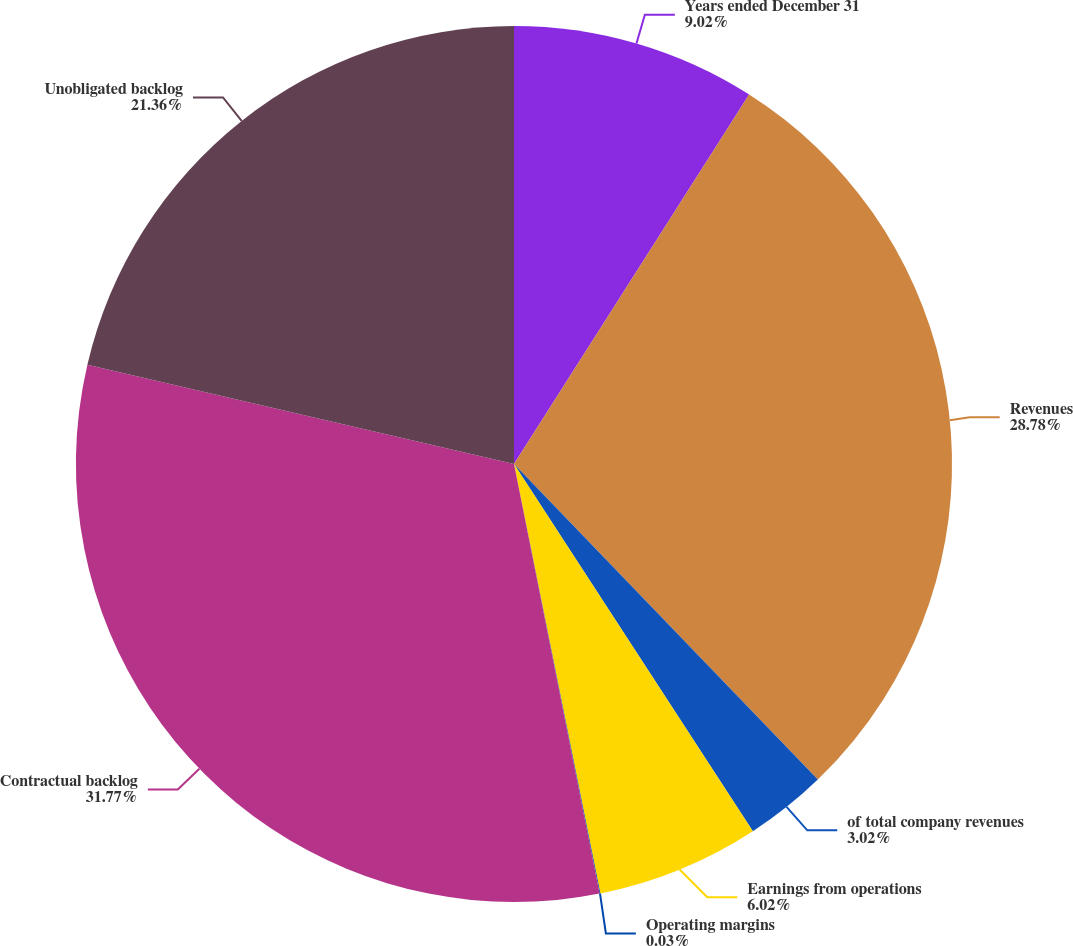Convert chart to OTSL. <chart><loc_0><loc_0><loc_500><loc_500><pie_chart><fcel>Years ended December 31<fcel>Revenues<fcel>of total company revenues<fcel>Earnings from operations<fcel>Operating margins<fcel>Contractual backlog<fcel>Unobligated backlog<nl><fcel>9.02%<fcel>28.78%<fcel>3.02%<fcel>6.02%<fcel>0.03%<fcel>31.77%<fcel>21.36%<nl></chart> 